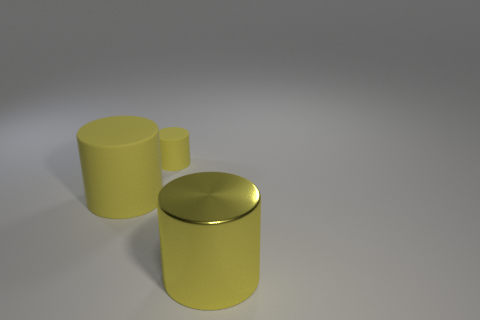Is the color of the small matte cylinder the same as the large rubber cylinder?
Offer a very short reply. Yes. There is a big cylinder on the left side of the big metallic object in front of the rubber cylinder in front of the tiny thing; what is its color?
Provide a short and direct response. Yellow. How many objects are behind the big yellow cylinder in front of the large cylinder that is left of the big yellow shiny cylinder?
Give a very brief answer. 2. Is there anything else that is the same color as the small rubber cylinder?
Provide a succinct answer. Yes. There is a cylinder that is behind the large yellow rubber thing; how many big yellow shiny cylinders are on the left side of it?
Provide a short and direct response. 0. Are there any objects left of the big object to the right of the yellow cylinder that is left of the tiny yellow rubber thing?
Ensure brevity in your answer.  Yes. There is another large thing that is the same shape as the big yellow rubber object; what is it made of?
Your answer should be compact. Metal. Is there anything else that has the same material as the small cylinder?
Your answer should be very brief. Yes. Does the small cylinder have the same material as the big cylinder left of the yellow metallic cylinder?
Ensure brevity in your answer.  Yes. There is a big thing left of the large yellow object to the right of the small yellow matte cylinder; what shape is it?
Provide a succinct answer. Cylinder. 